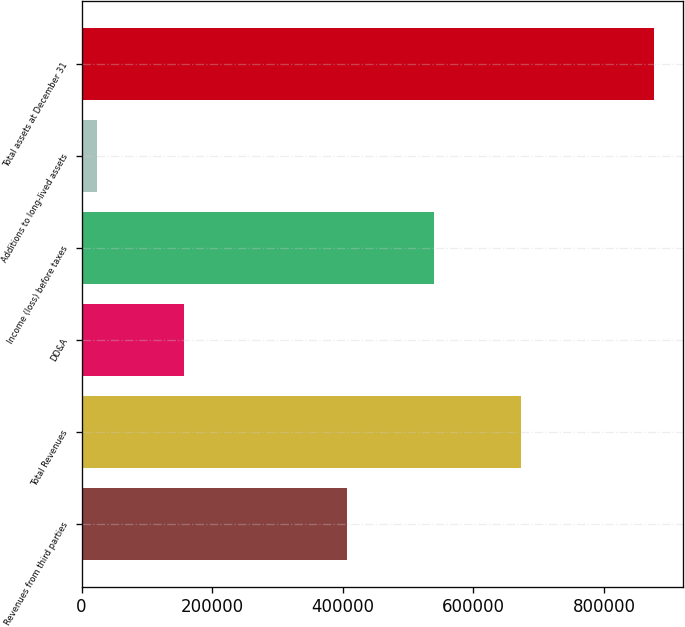Convert chart to OTSL. <chart><loc_0><loc_0><loc_500><loc_500><bar_chart><fcel>Revenues from third parties<fcel>Total Revenues<fcel>DD&A<fcel>Income (loss) before taxes<fcel>Additions to long-lived assets<fcel>Total assets at December 31<nl><fcel>405988<fcel>672278<fcel>156300<fcel>539133<fcel>23155<fcel>877409<nl></chart> 